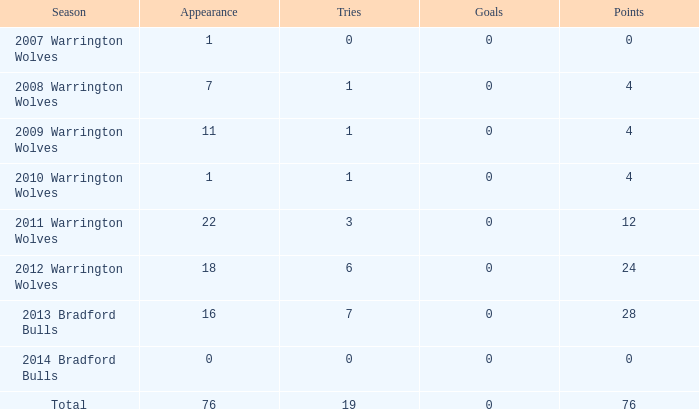What is the sum of appearance when goals is more than 0? None. 